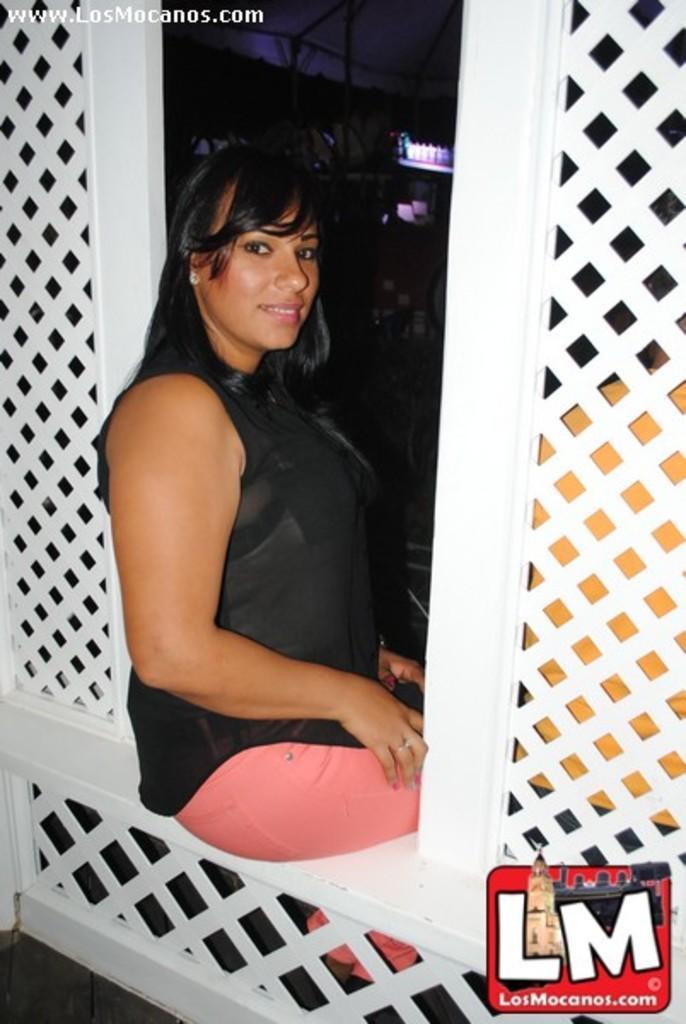How would you summarize this image in a sentence or two? In this image a woman is sitting on the fence. Right side there is a person sitting behind the fence. Background there are few shelves having few objects on it. 